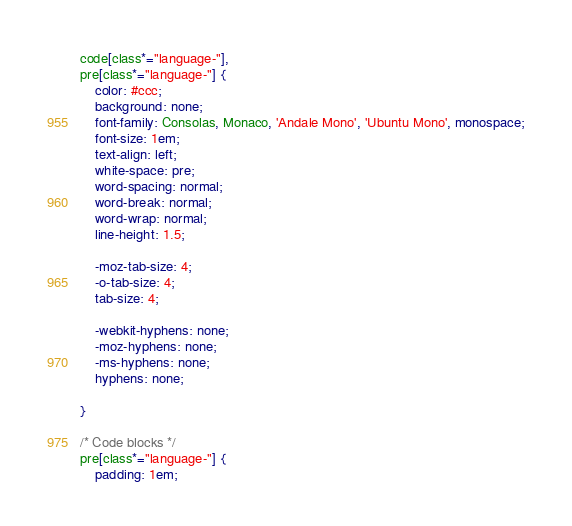<code> <loc_0><loc_0><loc_500><loc_500><_CSS_>code[class*="language-"],
pre[class*="language-"] {
	color: #ccc;
	background: none;
	font-family: Consolas, Monaco, 'Andale Mono', 'Ubuntu Mono', monospace;
	font-size: 1em;
	text-align: left;
	white-space: pre;
	word-spacing: normal;
	word-break: normal;
	word-wrap: normal;
	line-height: 1.5;

	-moz-tab-size: 4;
	-o-tab-size: 4;
	tab-size: 4;

	-webkit-hyphens: none;
	-moz-hyphens: none;
	-ms-hyphens: none;
	hyphens: none;

}

/* Code blocks */
pre[class*="language-"] {
	padding: 1em;</code> 